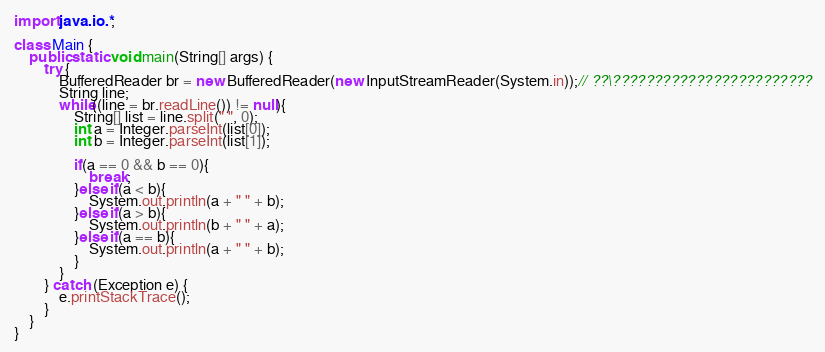Convert code to text. <code><loc_0><loc_0><loc_500><loc_500><_Java_>import java.io.*;

class Main {
    public static void main(String[] args) {
        try {
            BufferedReader br = new BufferedReader(new InputStreamReader(System.in));// ??\????????????????????????
            String line;
            while((line = br.readLine()) != null){
            	String[] list = line.split(" ", 0);
            	int a = Integer.parseInt(list[0]);
            	int b = Integer.parseInt(list[1]);
            	
            	if(a == 0 && b == 0){
            		break;
            	}else if(a < b){
            		System.out.println(a + " " + b);
            	}else if(a > b){
            		System.out.println(b + " " + a);
            	}else if(a == b){
            		System.out.println(a + " " + b);
            	}
            }
        } catch (Exception e) {
            e.printStackTrace();
        }
    }
}</code> 